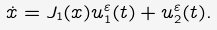<formula> <loc_0><loc_0><loc_500><loc_500>\dot { x } = J _ { 1 } ( x ) u _ { 1 } ^ { \varepsilon } ( t ) + u _ { 2 } ^ { \varepsilon } ( t ) .</formula> 